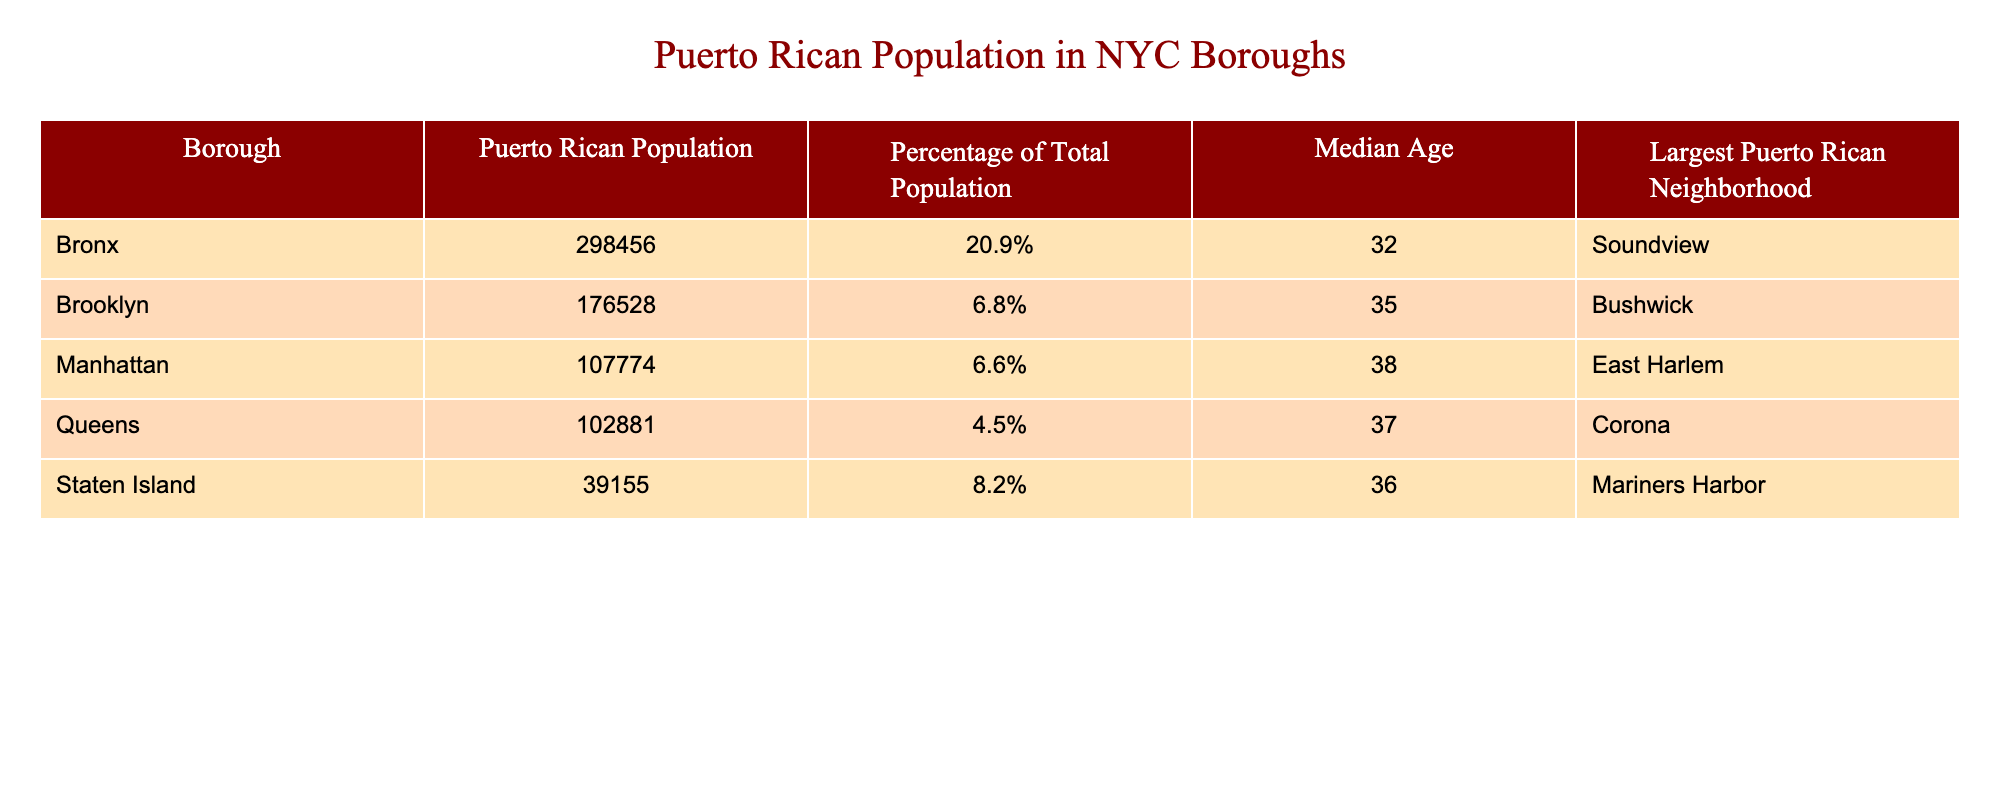What is the Puerto Rican population in the Bronx? The table shows the Puerto Rican population in the Bronx as 298,456.
Answer: 298,456 Which borough has the highest percentage of Puerto Rican population? The Bronx has a Puerto Rican population percentage of 20.9%, which is the highest among all the boroughs listed.
Answer: Bronx What is the median age of the Puerto Rican population in Brooklyn? The table lists the median age of the Puerto Rican population in Brooklyn as 35 years.
Answer: 35 How many more Puerto Ricans live in the Bronx compared to Staten Island? The Bronx has 298,456 Puerto Ricans, and Staten Island has 39,155. The difference is calculated as 298,456 - 39,155 = 259,301.
Answer: 259,301 What is the total Puerto Rican population across all boroughs listed? To find the total, we sum the Puerto Rican populations: 298,456 + 176,528 + 107,774 + 102,881 + 39,155 = 724,794.
Answer: 724,794 Does Manhattan have a higher Puerto Rican population percentage than Queens? Manhattan's percentage is 6.6% and Queens' is 4.5%, making it true that Manhattan has a higher percentage.
Answer: Yes Which borough has the largest Puerto Rican neighborhood, and what is the name of that neighborhood? The Bronx has the largest Puerto Rican neighborhood called Soundview, as indicated in the table.
Answer: Bronx, Soundview What is the average median age of the Puerto Rican populations across the listed boroughs? We sum the median ages of the Puerto Rican populations (32 + 35 + 38 + 37 + 36 = 178) and divide by the number of boroughs (5): 178 / 5 = 35.6.
Answer: 35.6 Is the average median age of Puerto Ricans in NYC greater than 35? The average median age calculated is 35.6, which is greater than 35, confirming the statement is true.
Answer: Yes How many Puerto Ricans live in Brooklyn compared to Manhattan? Brooklyn has 176,528 Puerto Ricans, while Manhattan has 107,774. The difference is 176,528 - 107,774 = 68,754 more in Brooklyn.
Answer: 68,754 